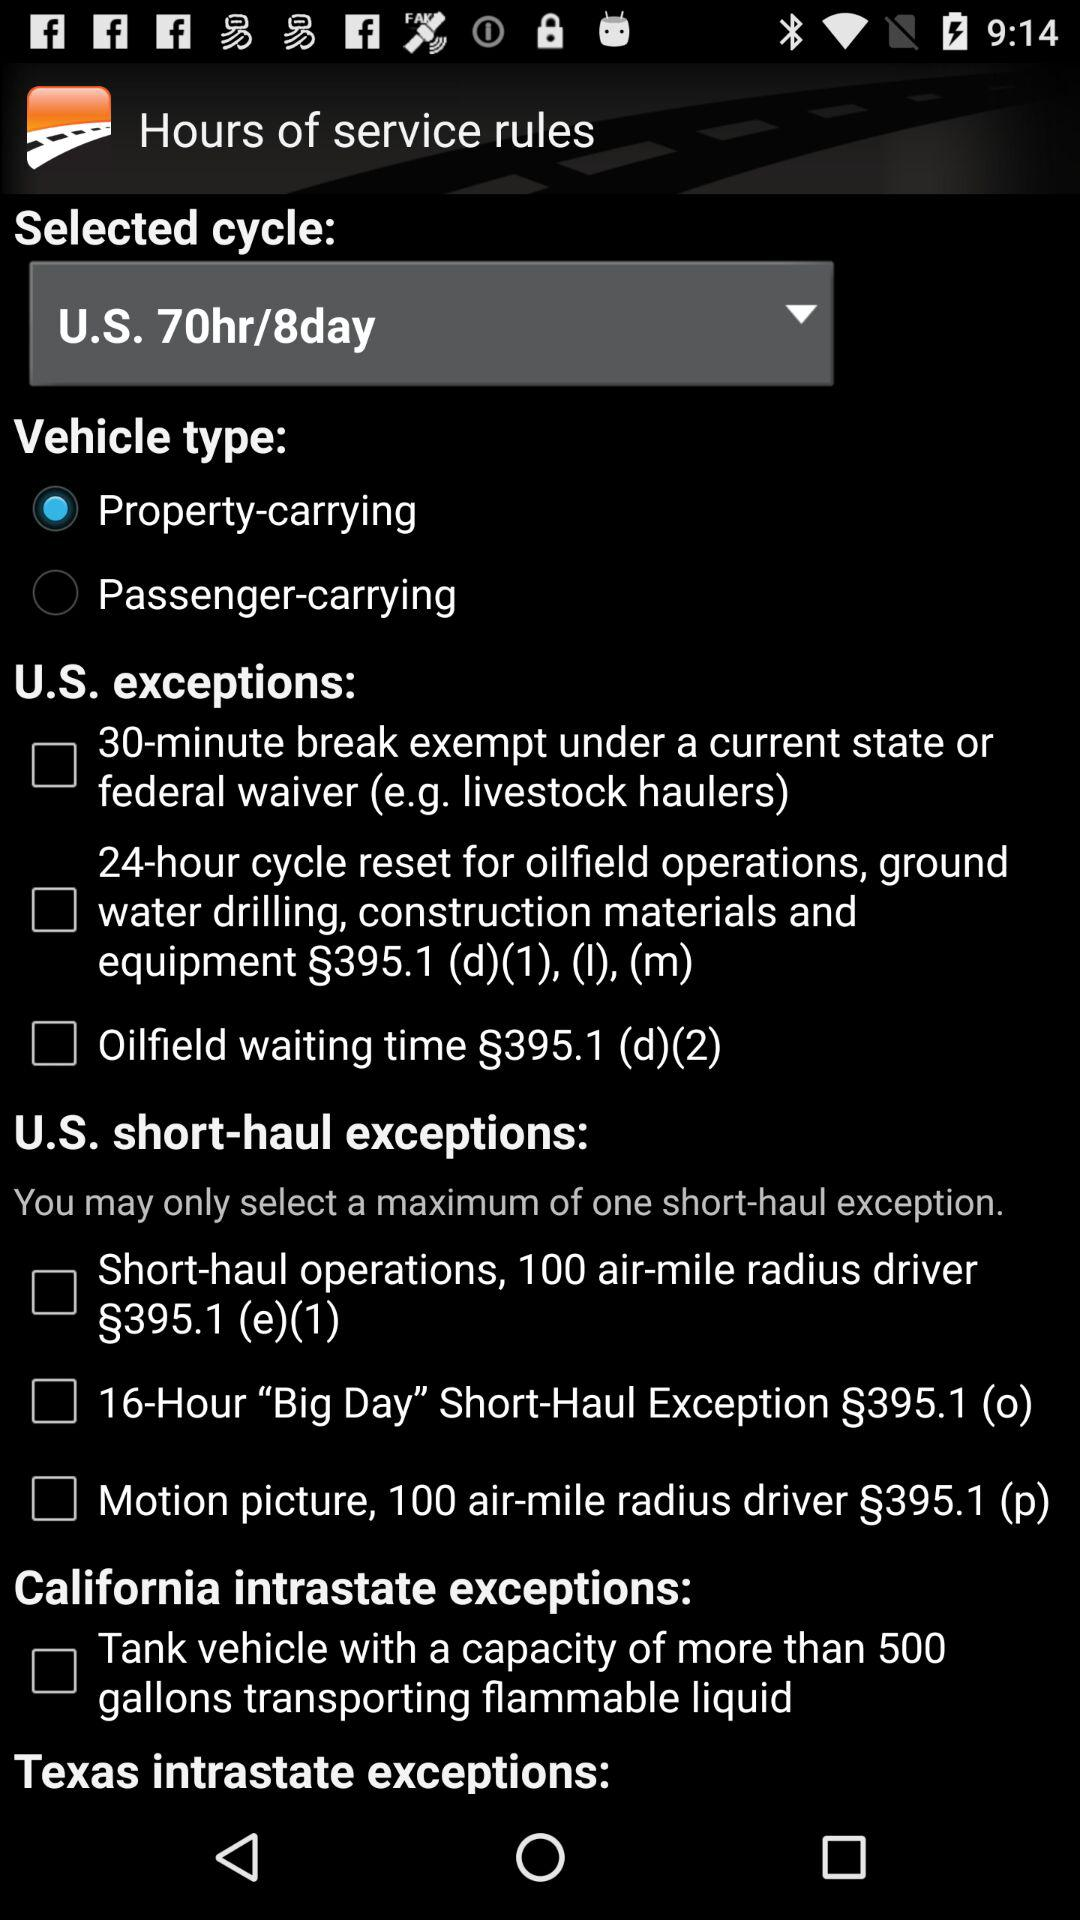How many vehicle type options are there?
Answer the question using a single word or phrase. 2 